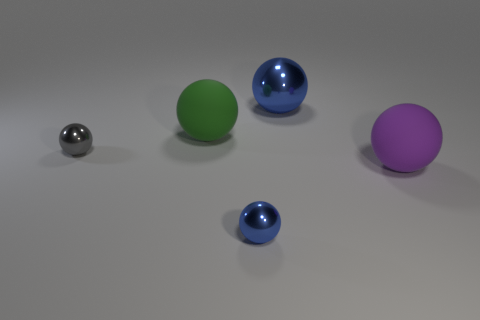Does the small gray thing have the same material as the blue ball that is behind the gray object?
Keep it short and to the point. Yes. There is a big matte object that is in front of the small gray sphere; is it the same shape as the large green matte thing?
Your answer should be compact. Yes. There is a tiny gray object that is the same shape as the purple rubber thing; what is it made of?
Your answer should be very brief. Metal. Is the shape of the green rubber thing the same as the metallic object on the right side of the tiny blue thing?
Give a very brief answer. Yes. What is the color of the large sphere that is both to the right of the green rubber ball and on the left side of the big purple thing?
Your response must be concise. Blue. Are any blue rubber objects visible?
Keep it short and to the point. No. Are there an equal number of metallic balls that are right of the tiny gray thing and big purple matte things?
Offer a very short reply. No. What number of other things are the same shape as the large green rubber object?
Your answer should be very brief. 4. Do the gray thing and the big blue object have the same material?
Give a very brief answer. Yes. Are there the same number of tiny shiny things on the right side of the large green object and metallic objects behind the tiny blue thing?
Provide a short and direct response. No. 